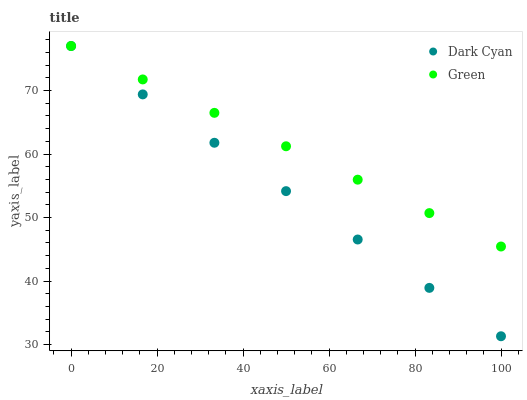Does Dark Cyan have the minimum area under the curve?
Answer yes or no. Yes. Does Green have the maximum area under the curve?
Answer yes or no. Yes. Does Green have the minimum area under the curve?
Answer yes or no. No. Is Green the smoothest?
Answer yes or no. Yes. Is Dark Cyan the roughest?
Answer yes or no. Yes. Is Green the roughest?
Answer yes or no. No. Does Dark Cyan have the lowest value?
Answer yes or no. Yes. Does Green have the lowest value?
Answer yes or no. No. Does Green have the highest value?
Answer yes or no. Yes. Does Dark Cyan intersect Green?
Answer yes or no. Yes. Is Dark Cyan less than Green?
Answer yes or no. No. Is Dark Cyan greater than Green?
Answer yes or no. No. 